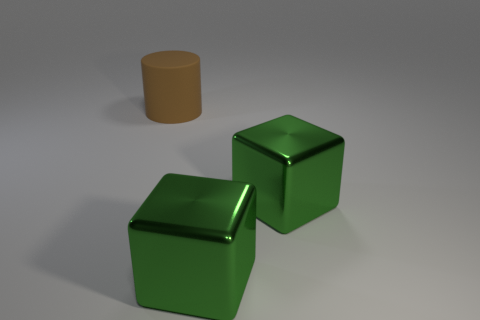What number of other objects are the same color as the rubber object?
Your answer should be compact. 0. What number of big objects are either shiny things or brown things?
Make the answer very short. 3. Are there any other things of the same size as the brown matte thing?
Provide a succinct answer. Yes. How many metallic objects are either green cubes or small cyan cubes?
Provide a short and direct response. 2. There is a brown rubber cylinder; how many green metal objects are right of it?
Provide a short and direct response. 2. How many matte objects are there?
Keep it short and to the point. 1. How big is the brown matte thing?
Your answer should be very brief. Large. What number of other objects are there of the same shape as the rubber object?
Give a very brief answer. 0. What number of things are big gray cylinders or big things to the right of the big brown rubber cylinder?
Your response must be concise. 2. Is there another brown cylinder made of the same material as the brown cylinder?
Provide a succinct answer. No. 